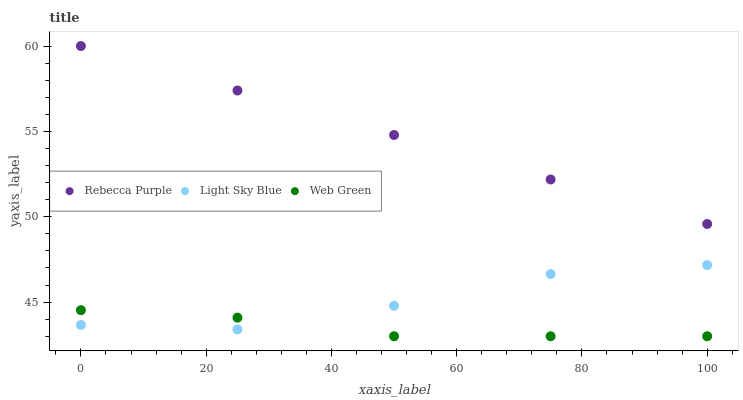Does Web Green have the minimum area under the curve?
Answer yes or no. Yes. Does Rebecca Purple have the maximum area under the curve?
Answer yes or no. Yes. Does Rebecca Purple have the minimum area under the curve?
Answer yes or no. No. Does Web Green have the maximum area under the curve?
Answer yes or no. No. Is Rebecca Purple the smoothest?
Answer yes or no. Yes. Is Light Sky Blue the roughest?
Answer yes or no. Yes. Is Web Green the smoothest?
Answer yes or no. No. Is Web Green the roughest?
Answer yes or no. No. Does Web Green have the lowest value?
Answer yes or no. Yes. Does Rebecca Purple have the lowest value?
Answer yes or no. No. Does Rebecca Purple have the highest value?
Answer yes or no. Yes. Does Web Green have the highest value?
Answer yes or no. No. Is Light Sky Blue less than Rebecca Purple?
Answer yes or no. Yes. Is Rebecca Purple greater than Web Green?
Answer yes or no. Yes. Does Light Sky Blue intersect Web Green?
Answer yes or no. Yes. Is Light Sky Blue less than Web Green?
Answer yes or no. No. Is Light Sky Blue greater than Web Green?
Answer yes or no. No. Does Light Sky Blue intersect Rebecca Purple?
Answer yes or no. No. 